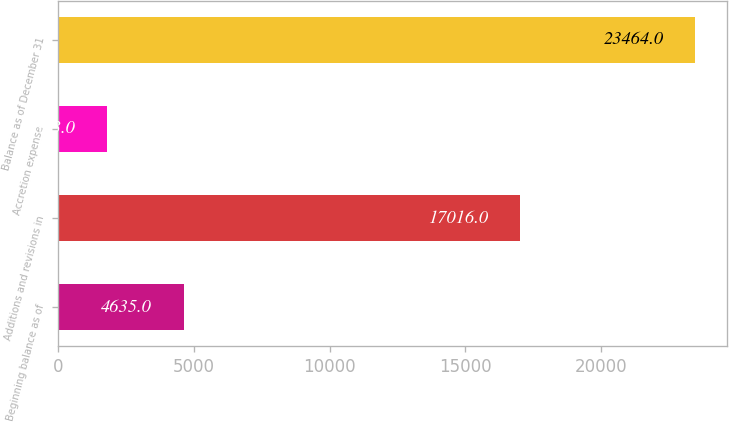Convert chart to OTSL. <chart><loc_0><loc_0><loc_500><loc_500><bar_chart><fcel>Beginning balance as of<fcel>Additions and revisions in<fcel>Accretion expense<fcel>Balance as of December 31<nl><fcel>4635<fcel>17016<fcel>1813<fcel>23464<nl></chart> 